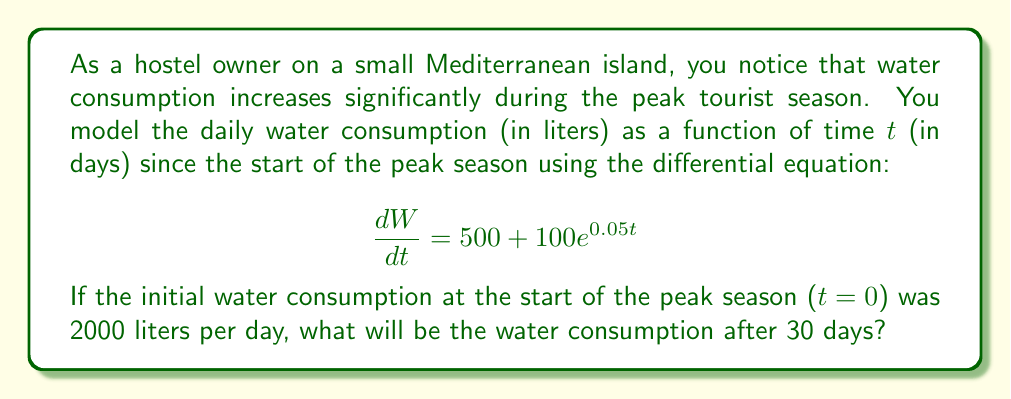Teach me how to tackle this problem. To solve this problem, we need to integrate the given differential equation and apply the initial condition. Let's break it down step by step:

1) The differential equation is:
   $$\frac{dW}{dt} = 500 + 100e^{0.05t}$$

2) To find $W(t)$, we integrate both sides with respect to $t$:
   $$W(t) = \int (500 + 100e^{0.05t}) dt$$

3) Integrating the right-hand side:
   $$W(t) = 500t + 100 \cdot \frac{1}{0.05}e^{0.05t} + C$$
   $$W(t) = 500t + 2000e^{0.05t} + C$$

4) Now we use the initial condition to find $C$. We know that $W(0) = 2000$:
   $$2000 = 500(0) + 2000e^{0.05(0)} + C$$
   $$2000 = 2000 + C$$
   $$C = 0$$

5) Therefore, our solution is:
   $$W(t) = 500t + 2000e^{0.05t}$$

6) To find the water consumption after 30 days, we substitute $t=30$:
   $$W(30) = 500(30) + 2000e^{0.05(30)}$$
   $$W(30) = 15000 + 2000e^{1.5}$$
   $$W(30) = 15000 + 2000(4.4817)$$
   $$W(30) = 15000 + 8963.4$$
   $$W(30) = 23963.4$$

Thus, after 30 days, the water consumption will be approximately 23,963.4 liters per day.
Answer: The water consumption after 30 days will be approximately 23,963.4 liters per day. 